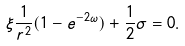Convert formula to latex. <formula><loc_0><loc_0><loc_500><loc_500>\xi \frac { 1 } { r ^ { 2 } } ( 1 - e ^ { - 2 \omega } ) + \frac { 1 } { 2 } \sigma = 0 .</formula> 